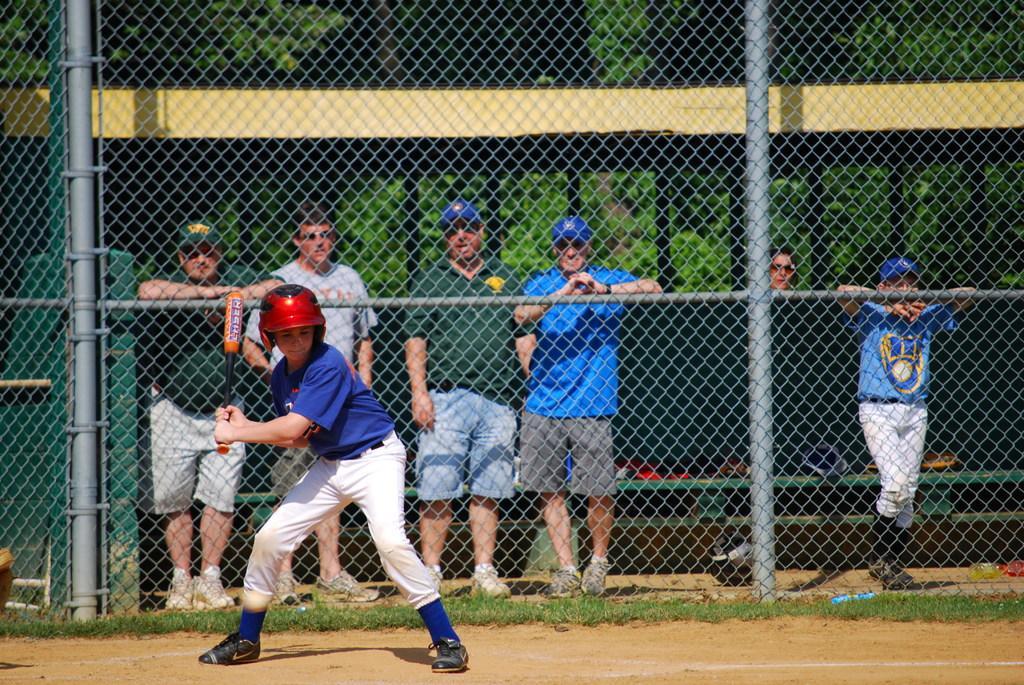Could you give a brief overview of what you see in this image? In this image there is a person holding the baseball stick. Behind him there are people holding the metal fence. In the background of the image there are trees. 